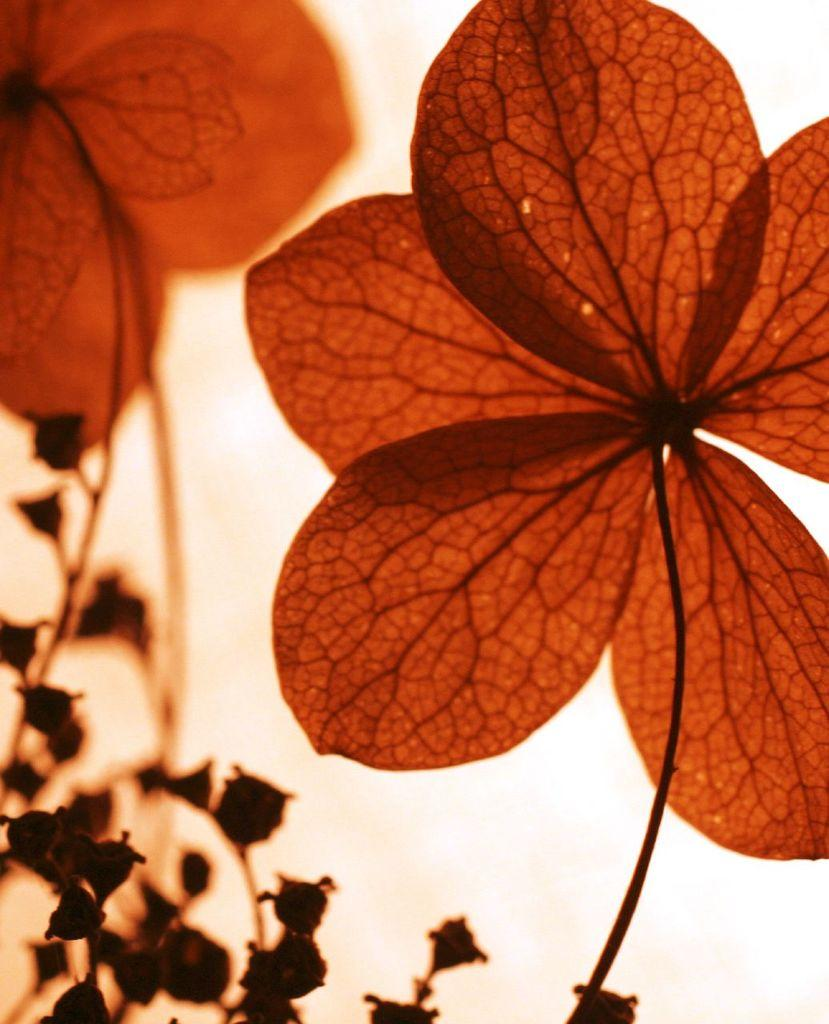What is present in the image? There is a plant in the image. Can you describe any other visual elements in the image? There is a light reflection in the image. What discovery was made by the plant's partner in the image? There is no partner mentioned in the image, and no discovery is depicted. 